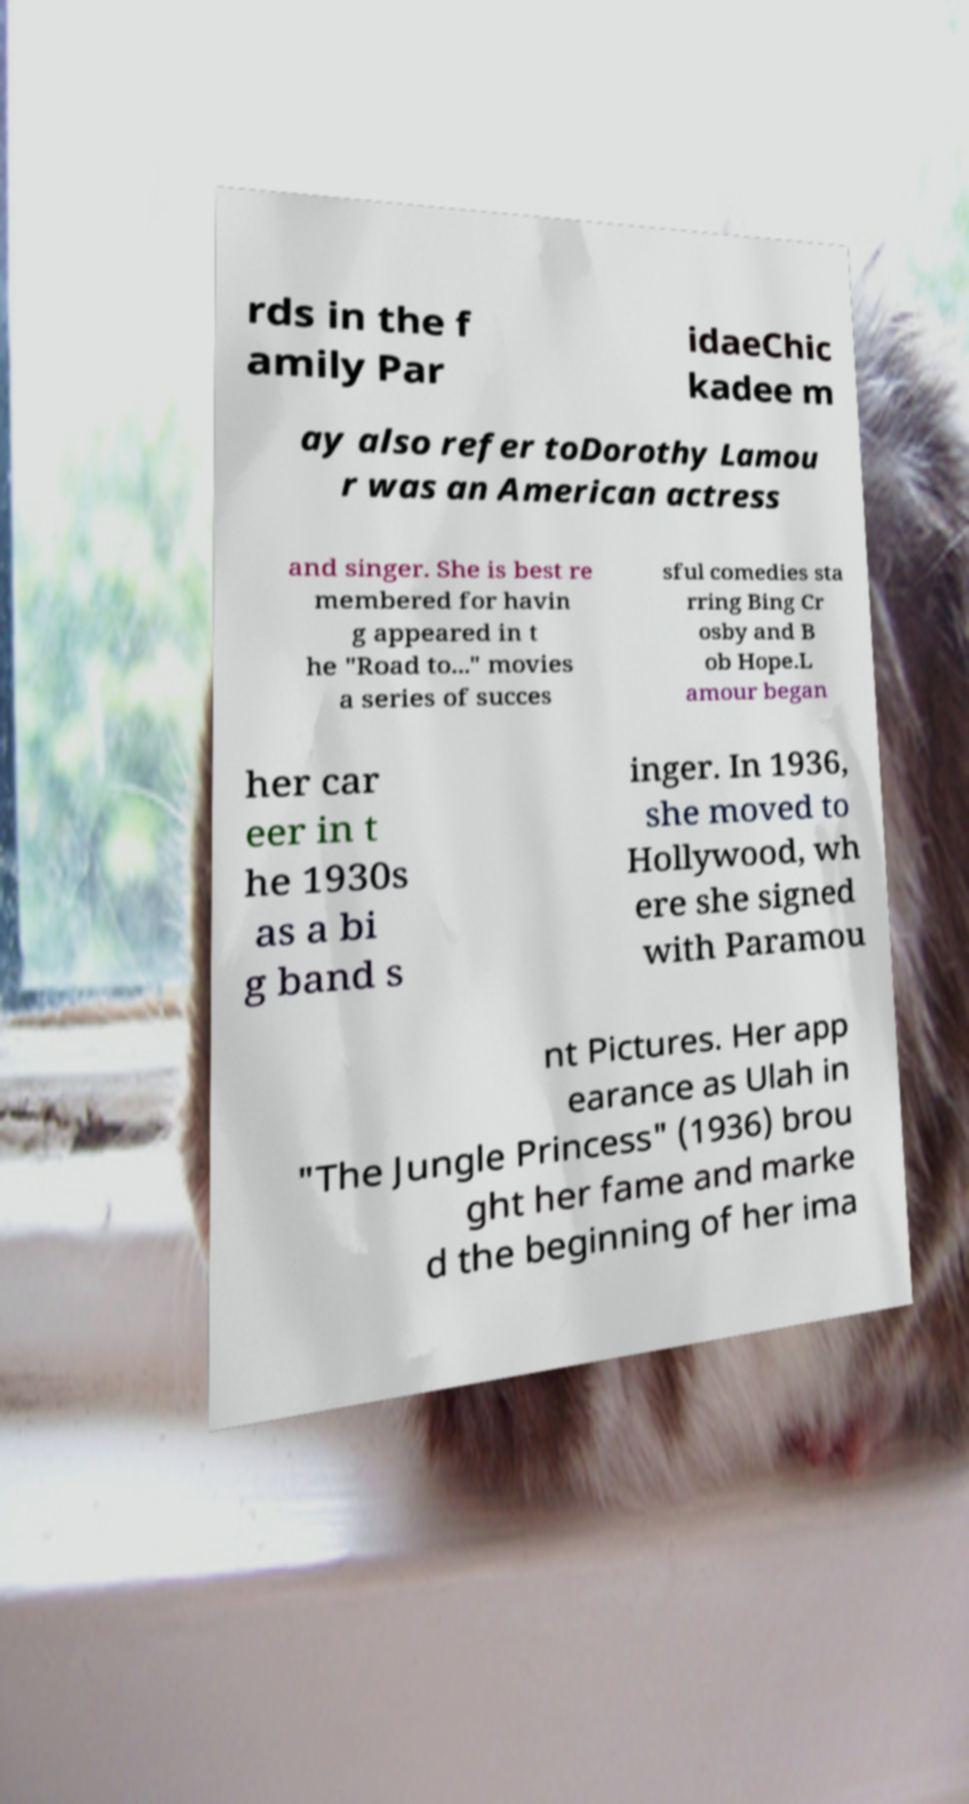Can you accurately transcribe the text from the provided image for me? rds in the f amily Par idaeChic kadee m ay also refer toDorothy Lamou r was an American actress and singer. She is best re membered for havin g appeared in t he "Road to..." movies a series of succes sful comedies sta rring Bing Cr osby and B ob Hope.L amour began her car eer in t he 1930s as a bi g band s inger. In 1936, she moved to Hollywood, wh ere she signed with Paramou nt Pictures. Her app earance as Ulah in "The Jungle Princess" (1936) brou ght her fame and marke d the beginning of her ima 